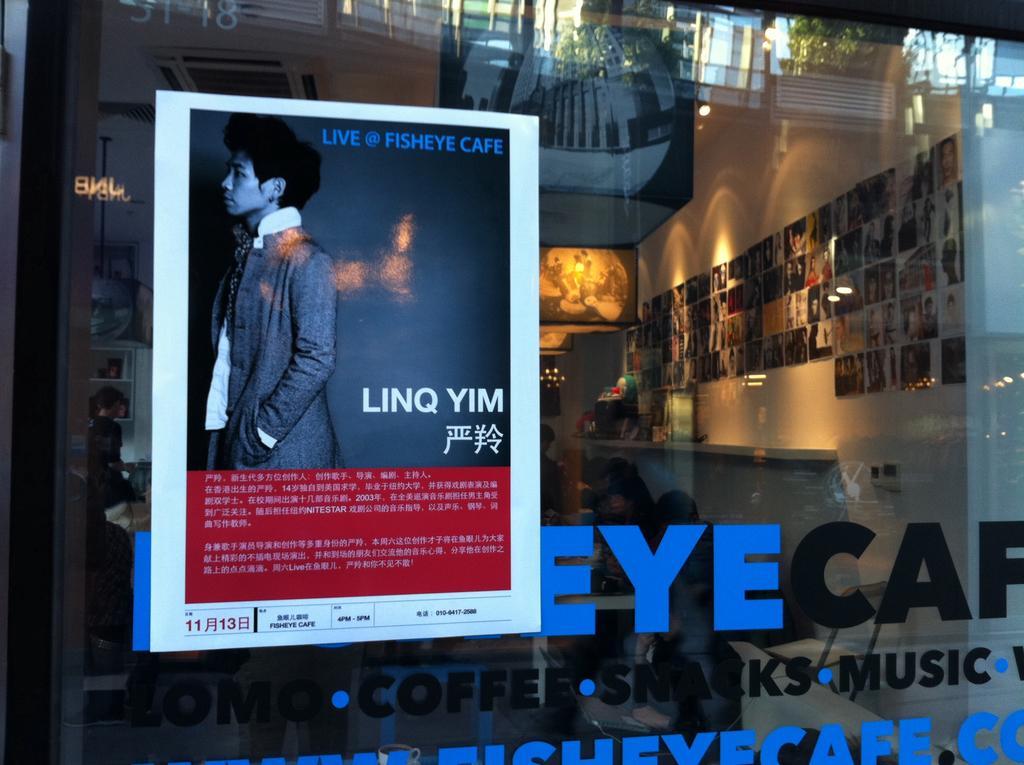Describe this image in one or two sentences. In this image we can see a store. On the right side of the image we can see photos, bench and some objects, screen are there. On the left side of the image we can see a poster, boy, wall are there. At the bottom of the image we can see some text is there. 